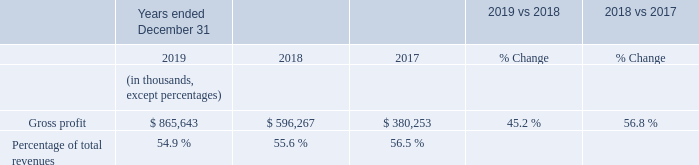Gross Profit
Gross profit increased $269.4 million, or 45.2%, for the year ended December 31, 2019 compared to the same period in 2018. As a percentage of total revenues, gross profit decreased from 55.6% in the year ended December 31, 2018 to 54.9% in the year ended December 31, 2019, due to Shopify Payments representing a larger percentage of total revenue and an increase in amortization of technology related to the 6RS acquisition as well as other platform enhancements. This was partly offset by lower third-party infrastructure and hosting costs and employee-related costs as a percentage of revenues as well as the relative growth of higher-margin merchant solutions products, namely Shopify Capital and referral fees from partners.
Gross profit increased $216.0 million, or 56.8%, for the year ended December 31, 2018 compared to the same period in 2017. As a percentage of total revenues, gross profit decreased from 56.5% in the year ended December 31, 2017 to 55.6% in the year ended December 31, 2018, due to Shopify Payments representing a larger percentage of total revenue, increasing the functionality and flexibility of our hosting infrastructure, and higher product costs associated with expanding our product offerings. This was partly offset by the relative growth of higher-margin merchant solutions products, namely referral fees from partners, Shopify Capital, and Shopify Shipping.
What is the gross profit as at year ended December 31, 2019?
Answer scale should be: thousand. $ 865,643. What is the gross profit as at year ended December 31, 2018?
Answer scale should be: thousand. $ 596,267. What is the gross profit as at year ended December 31, 2017?
Answer scale should be: thousand. $ 380,253. Between year ended 2018 and 2019, which year had higher gross profit? 865,643>596,267
Answer: 2019. Between year ended 2017 and 2018, which year had higher gross profit? 596,267>380,253
Answer: 2018. What is the average gross profit for 2018 and 2019?
Answer scale should be: thousand. (865,643+596,267)/2
Answer: 730955. 